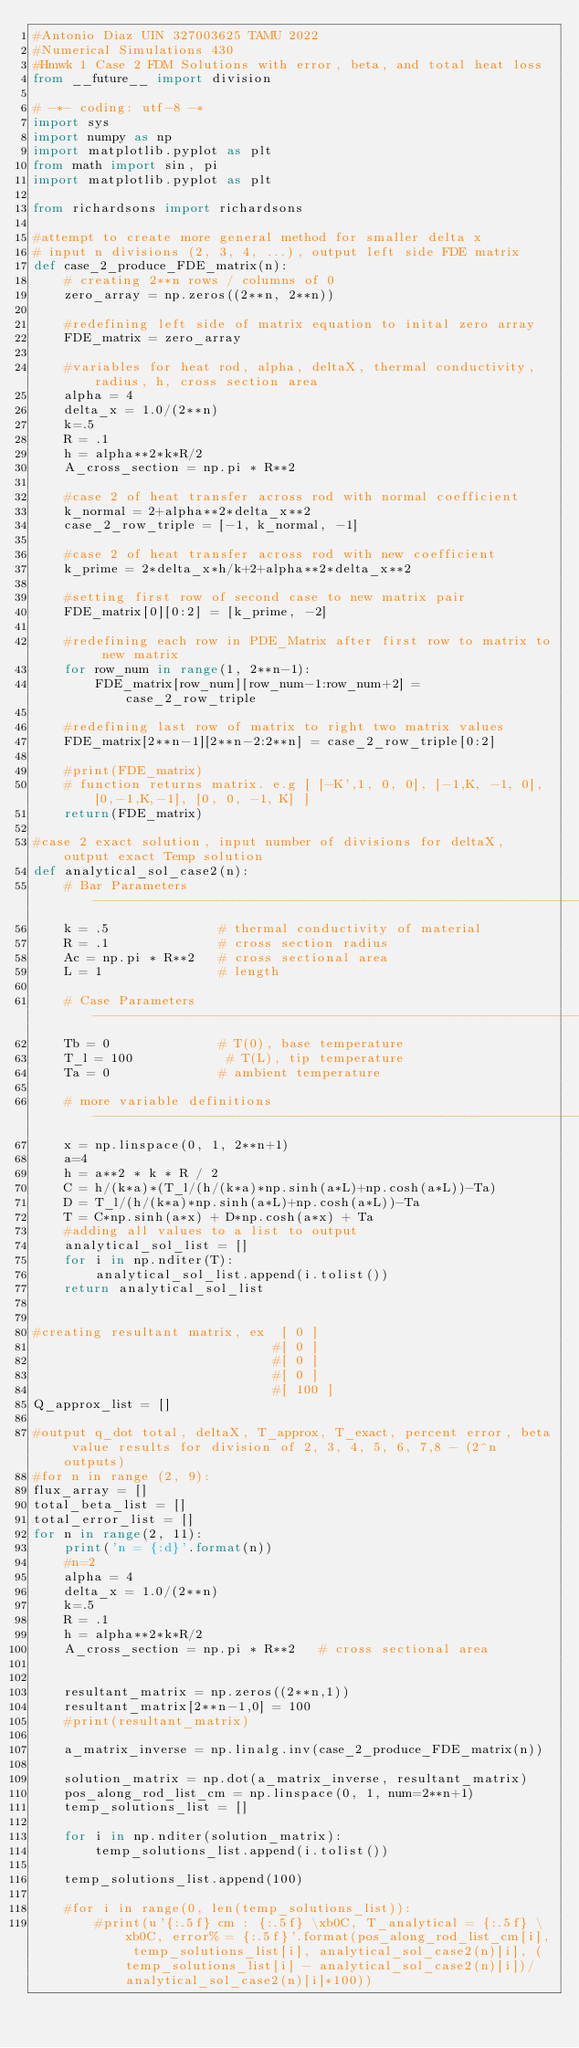Convert code to text. <code><loc_0><loc_0><loc_500><loc_500><_Python_>#Antonio Diaz UIN 327003625 TAMU 2022
#Numerical Simulations 430 
#Hmwk 1 Case 2 FDM Solutions with error, beta, and total heat loss
from __future__ import division

# -*- coding: utf-8 -*
import sys
import numpy as np
import matplotlib.pyplot as plt
from math import sin, pi
import matplotlib.pyplot as plt

from richardsons import richardsons

#attempt to create more general method for smaller delta x
# input n divisions (2, 3, 4, ...), output left side FDE matrix
def case_2_produce_FDE_matrix(n):
    # creating 2**n rows / columns of 0 
    zero_array = np.zeros((2**n, 2**n))

    #redefining left side of matrix equation to inital zero array
    FDE_matrix = zero_array
   
    #variables for heat rod, alpha, deltaX, thermal conductivity, radius, h, cross section area
    alpha = 4
    delta_x = 1.0/(2**n)
    k=.5
    R = .1
    h = alpha**2*k*R/2
    A_cross_section = np.pi * R**2  

    #case 2 of heat transfer across rod with normal coefficient
    k_normal = 2+alpha**2*delta_x**2
    case_2_row_triple = [-1, k_normal, -1]

    #case 2 of heat transfer across rod with new coefficient
    k_prime = 2*delta_x*h/k+2+alpha**2*delta_x**2
   
    #setting first row of second case to new matrix pair
    FDE_matrix[0][0:2] = [k_prime, -2]

    #redefining each row in PDE_Matrix after first row to matrix to new matrix
    for row_num in range(1, 2**n-1):
        FDE_matrix[row_num][row_num-1:row_num+2] = case_2_row_triple

    #redefining last row of matrix to right two matrix values
    FDE_matrix[2**n-1][2**n-2:2**n] = case_2_row_triple[0:2]

    #print(FDE_matrix)
    # function returns matrix. e.g [ [-K',1, 0, 0], [-1,K, -1, 0], [0,-1,K,-1], [0, 0, -1, K] ]
    return(FDE_matrix)

#case 2 exact solution, input number of divisions for deltaX, output exact Temp solution
def analytical_sol_case2(n):
    # Bar Parameters ----------------------------------------------------------------------------------------------------------------------------------
    k = .5              # thermal conductivity of material
    R = .1              # cross section radius
    Ac = np.pi * R**2   # cross sectional area
    L = 1               # length

    # Case Parameters -----------------------------------------------------------------------------------------------------------------------------
    Tb = 0              # T(0), base temperature
    T_l = 100            # T(L), tip temperature
    Ta = 0              # ambient temperature

    # more variable definitions ----------------------------------------------------------------------------------------------------------------------------
    x = np.linspace(0, 1, 2**n+1)   
    a=4
    h = a**2 * k * R / 2
    C = h/(k*a)*(T_l/(h/(k*a)*np.sinh(a*L)+np.cosh(a*L))-Ta)
    D = T_l/(h/(k*a)*np.sinh(a*L)+np.cosh(a*L))-Ta
    T = C*np.sinh(a*x) + D*np.cosh(a*x) + Ta
    #adding all values to a list to output
    analytical_sol_list = []
    for i in np.nditer(T):
        analytical_sol_list.append(i.tolist())
    return analytical_sol_list


#creating resultant matrix, ex  [ 0 ] 
                               #[ 0 ]
                               #[ 0 ]
                               #[ 0 ]
                               #[ 100 ]
Q_approx_list = []

#output q_dot total, deltaX, T_approx, T_exact, percent error, beta value results for division of 2, 3, 4, 5, 6, 7,8 - (2^n outputs)
#for n in range (2, 9):
flux_array = []
total_beta_list = []
total_error_list = []
for n in range(2, 11):
    print('n = {:d}'.format(n))
    #n=2
    alpha = 4
    delta_x = 1.0/(2**n)
    k=.5
    R = .1
    h = alpha**2*k*R/2
    A_cross_section = np.pi * R**2   # cross sectional area
  

    resultant_matrix = np.zeros((2**n,1))
    resultant_matrix[2**n-1,0] = 100
    #print(resultant_matrix)

    a_matrix_inverse = np.linalg.inv(case_2_produce_FDE_matrix(n))

    solution_matrix = np.dot(a_matrix_inverse, resultant_matrix)
    pos_along_rod_list_cm = np.linspace(0, 1, num=2**n+1)
    temp_solutions_list = []

    for i in np.nditer(solution_matrix):
        temp_solutions_list.append(i.tolist())

    temp_solutions_list.append(100)

    #for i in range(0, len(temp_solutions_list)):
        #print(u'{:.5f} cm : {:.5f} \xb0C, T_analytical = {:.5f} \xb0C, error% = {:.5f}'.format(pos_along_rod_list_cm[i], temp_solutions_list[i], analytical_sol_case2(n)[i], (temp_solutions_list[i] - analytical_sol_case2(n)[i])/analytical_sol_case2(n)[i]*100))</code> 